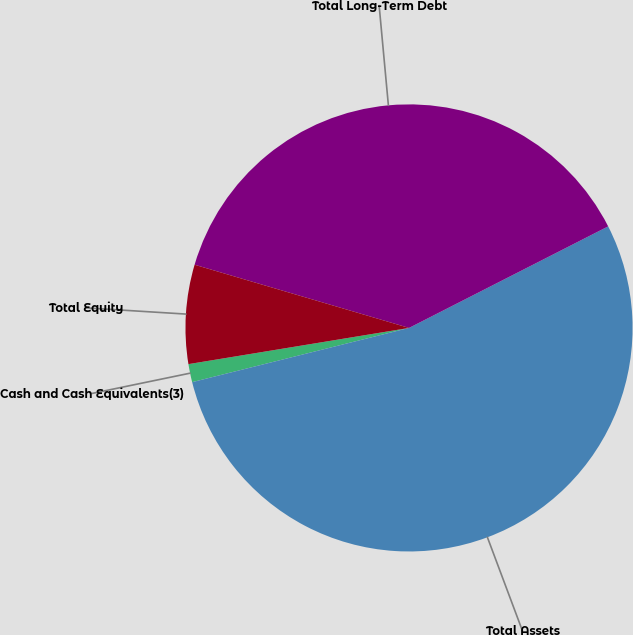Convert chart. <chart><loc_0><loc_0><loc_500><loc_500><pie_chart><fcel>Cash and Cash Equivalents(3)<fcel>Total Assets<fcel>Total Long-Term Debt<fcel>Total Equity<nl><fcel>1.31%<fcel>53.6%<fcel>37.93%<fcel>7.15%<nl></chart> 